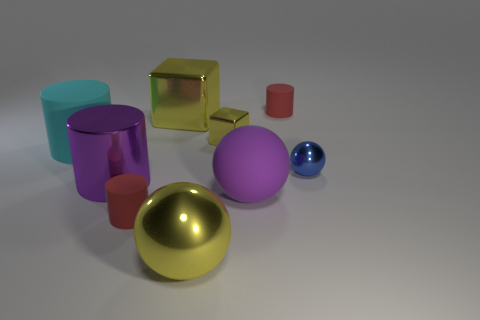Subtract all big yellow spheres. How many spheres are left? 2 Add 1 small cubes. How many objects exist? 10 Subtract all blocks. How many objects are left? 7 Subtract all yellow balls. How many balls are left? 2 Subtract 2 cylinders. How many cylinders are left? 2 Add 2 big cylinders. How many big cylinders are left? 4 Add 2 tiny yellow blocks. How many tiny yellow blocks exist? 3 Subtract 1 blue balls. How many objects are left? 8 Subtract all purple cylinders. Subtract all blue blocks. How many cylinders are left? 3 Subtract all red cylinders. How many green cubes are left? 0 